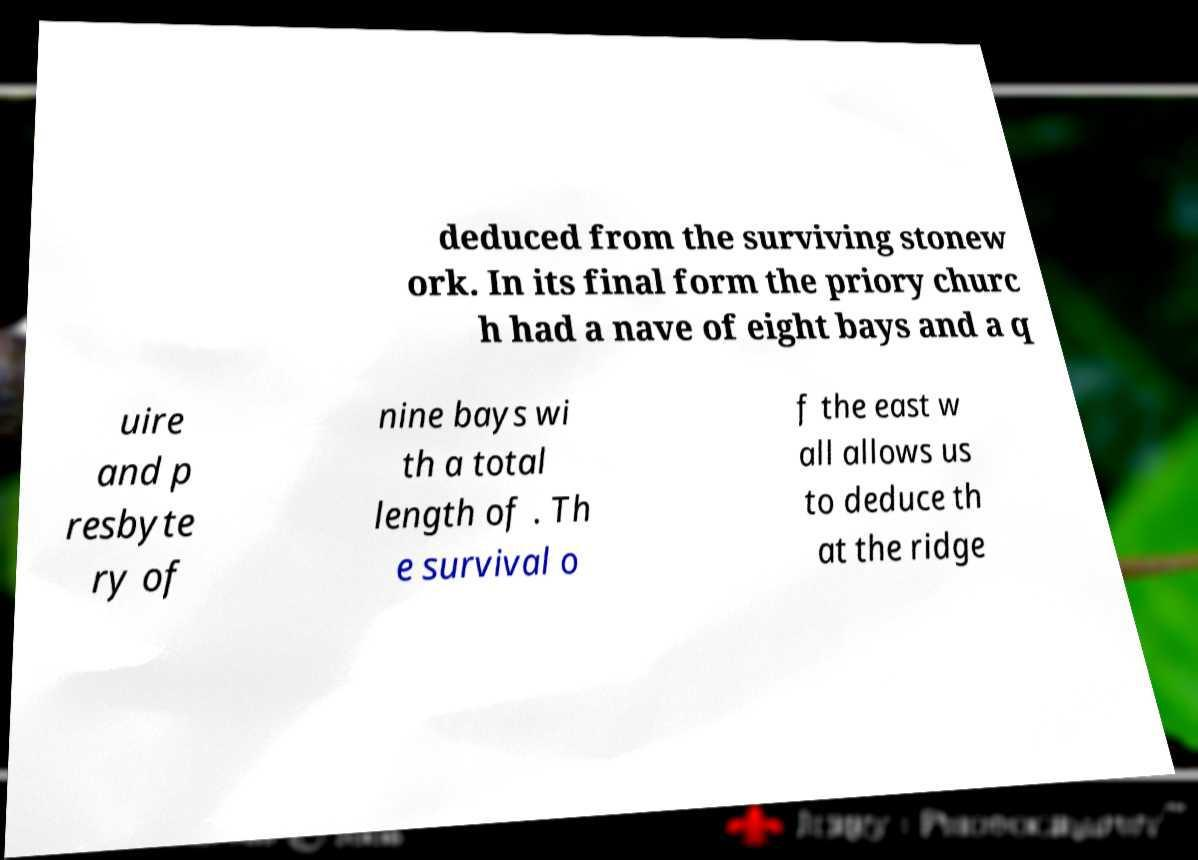Please read and relay the text visible in this image. What does it say? deduced from the surviving stonew ork. In its final form the priory churc h had a nave of eight bays and a q uire and p resbyte ry of nine bays wi th a total length of . Th e survival o f the east w all allows us to deduce th at the ridge 